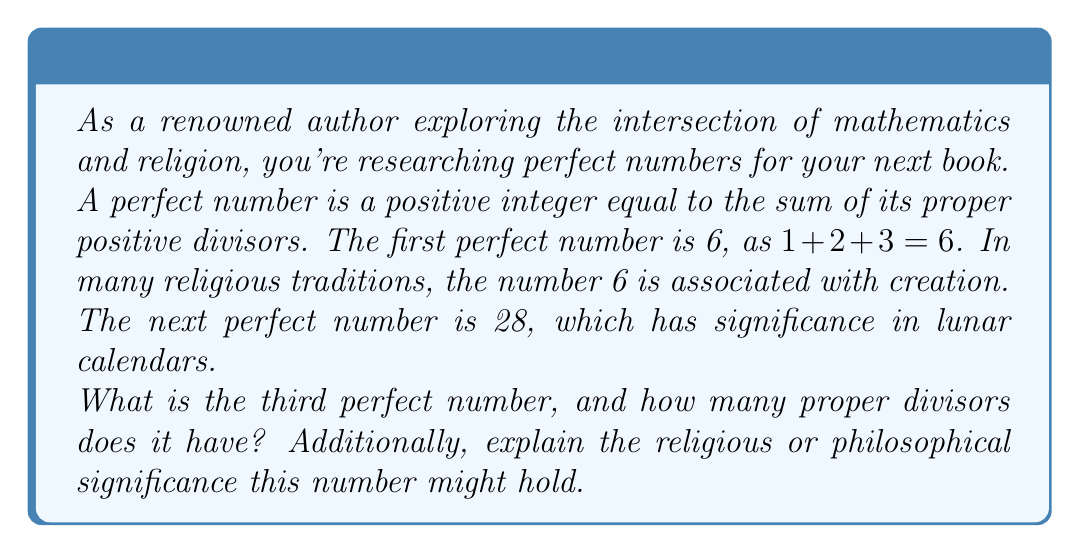Can you solve this math problem? To find the third perfect number and its proper divisors, we need to follow these steps:

1) First, let's recall the formula for generating perfect numbers:

   $P_n = 2^{p-1}(2^p - 1)$

   where $p$ is a prime number and $(2^p - 1)$ is also prime (known as a Mersenne prime).

2) We know the first two perfect numbers:
   - $P_1 = 6 = 2^1(2^2 - 1)$
   - $P_2 = 28 = 2^2(2^3 - 1)$

3) For the third perfect number, we need the next prime $p$ where $(2^p - 1)$ is also prime:
   - For $p = 5$, $2^5 - 1 = 31$, which is prime.

4) Therefore, the third perfect number is:
   $P_3 = 2^4(2^5 - 1) = 16 \times 31 = 496$

5) To find its proper divisors, we list all positive divisors less than 496:
   1, 2, 4, 8, 16, 31, 62, 124, 248

6) Count the number of proper divisors: There are 9 proper divisors.

Regarding religious or philosophical significance:

- In Judaism, 496 is the numerical value (gematria) of the word "Malkuth" (מלכות), meaning "kingdom" or "sovereignty" in Hebrew. This concept is significant in Kabbalah, representing the material world and God's presence within it.

- In Christianity, some theologians have noted that 496 years passed between the construction of Solomon's Temple and the decree of Artaxerxes to rebuild Jerusalem, linking it to themes of divine timing and restoration.

- In numerology, 496 reduces to 1 (4+9+6 = 19, 1+9 = 10, 1+0 = 1), symbolizing new beginnings, unity, and the divine source.

These connections could provide rich material for exploring the interplay between mathematics, numerology, and religious symbolism in your comparative religion and philosophy book.
Answer: The third perfect number is 496, and it has 9 proper divisors. 